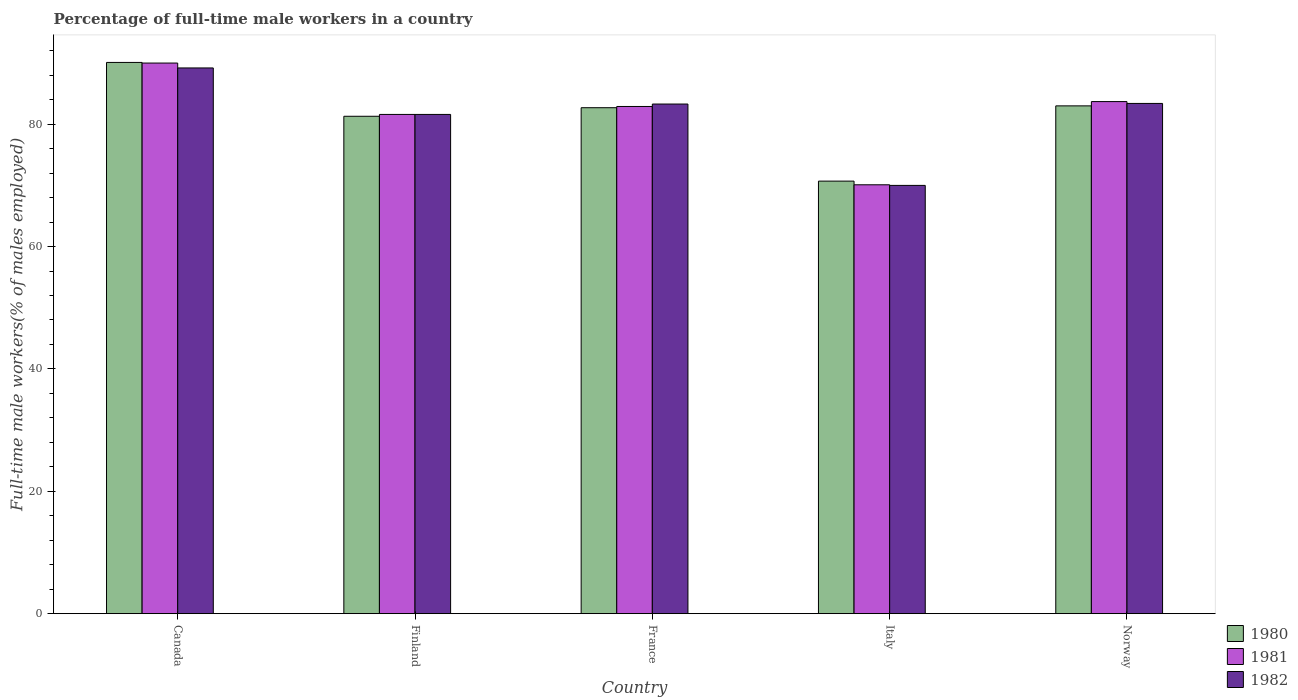How many different coloured bars are there?
Make the answer very short. 3. Are the number of bars per tick equal to the number of legend labels?
Make the answer very short. Yes. How many bars are there on the 1st tick from the left?
Provide a short and direct response. 3. What is the percentage of full-time male workers in 1980 in Canada?
Keep it short and to the point. 90.1. Across all countries, what is the maximum percentage of full-time male workers in 1981?
Give a very brief answer. 90. Across all countries, what is the minimum percentage of full-time male workers in 1982?
Give a very brief answer. 70. In which country was the percentage of full-time male workers in 1980 minimum?
Your answer should be compact. Italy. What is the total percentage of full-time male workers in 1980 in the graph?
Provide a succinct answer. 407.8. What is the difference between the percentage of full-time male workers in 1980 in Canada and that in Finland?
Provide a succinct answer. 8.8. What is the difference between the percentage of full-time male workers in 1981 in Italy and the percentage of full-time male workers in 1982 in Finland?
Your answer should be compact. -11.5. What is the average percentage of full-time male workers in 1980 per country?
Your answer should be compact. 81.56. What is the difference between the percentage of full-time male workers of/in 1980 and percentage of full-time male workers of/in 1981 in Canada?
Keep it short and to the point. 0.1. In how many countries, is the percentage of full-time male workers in 1982 greater than 4 %?
Your answer should be very brief. 5. What is the ratio of the percentage of full-time male workers in 1981 in France to that in Norway?
Offer a terse response. 0.99. Is the percentage of full-time male workers in 1982 in Canada less than that in France?
Make the answer very short. No. Is the difference between the percentage of full-time male workers in 1980 in Canada and Italy greater than the difference between the percentage of full-time male workers in 1981 in Canada and Italy?
Provide a succinct answer. No. What is the difference between the highest and the second highest percentage of full-time male workers in 1982?
Provide a short and direct response. 5.9. What is the difference between the highest and the lowest percentage of full-time male workers in 1980?
Your response must be concise. 19.4. What does the 1st bar from the right in Norway represents?
Give a very brief answer. 1982. Is it the case that in every country, the sum of the percentage of full-time male workers in 1981 and percentage of full-time male workers in 1982 is greater than the percentage of full-time male workers in 1980?
Give a very brief answer. Yes. How many bars are there?
Offer a very short reply. 15. Are all the bars in the graph horizontal?
Provide a short and direct response. No. What is the difference between two consecutive major ticks on the Y-axis?
Make the answer very short. 20. Are the values on the major ticks of Y-axis written in scientific E-notation?
Provide a short and direct response. No. Does the graph contain any zero values?
Make the answer very short. No. Does the graph contain grids?
Keep it short and to the point. No. Where does the legend appear in the graph?
Your answer should be compact. Bottom right. What is the title of the graph?
Keep it short and to the point. Percentage of full-time male workers in a country. What is the label or title of the X-axis?
Keep it short and to the point. Country. What is the label or title of the Y-axis?
Make the answer very short. Full-time male workers(% of males employed). What is the Full-time male workers(% of males employed) in 1980 in Canada?
Ensure brevity in your answer.  90.1. What is the Full-time male workers(% of males employed) in 1981 in Canada?
Your answer should be compact. 90. What is the Full-time male workers(% of males employed) of 1982 in Canada?
Your answer should be very brief. 89.2. What is the Full-time male workers(% of males employed) of 1980 in Finland?
Offer a very short reply. 81.3. What is the Full-time male workers(% of males employed) in 1981 in Finland?
Make the answer very short. 81.6. What is the Full-time male workers(% of males employed) in 1982 in Finland?
Provide a succinct answer. 81.6. What is the Full-time male workers(% of males employed) in 1980 in France?
Offer a very short reply. 82.7. What is the Full-time male workers(% of males employed) in 1981 in France?
Your response must be concise. 82.9. What is the Full-time male workers(% of males employed) in 1982 in France?
Offer a very short reply. 83.3. What is the Full-time male workers(% of males employed) in 1980 in Italy?
Make the answer very short. 70.7. What is the Full-time male workers(% of males employed) in 1981 in Italy?
Keep it short and to the point. 70.1. What is the Full-time male workers(% of males employed) of 1982 in Italy?
Give a very brief answer. 70. What is the Full-time male workers(% of males employed) in 1980 in Norway?
Ensure brevity in your answer.  83. What is the Full-time male workers(% of males employed) of 1981 in Norway?
Your response must be concise. 83.7. What is the Full-time male workers(% of males employed) of 1982 in Norway?
Ensure brevity in your answer.  83.4. Across all countries, what is the maximum Full-time male workers(% of males employed) of 1980?
Give a very brief answer. 90.1. Across all countries, what is the maximum Full-time male workers(% of males employed) of 1981?
Make the answer very short. 90. Across all countries, what is the maximum Full-time male workers(% of males employed) in 1982?
Your answer should be very brief. 89.2. Across all countries, what is the minimum Full-time male workers(% of males employed) of 1980?
Offer a very short reply. 70.7. Across all countries, what is the minimum Full-time male workers(% of males employed) of 1981?
Give a very brief answer. 70.1. Across all countries, what is the minimum Full-time male workers(% of males employed) in 1982?
Your response must be concise. 70. What is the total Full-time male workers(% of males employed) in 1980 in the graph?
Your answer should be compact. 407.8. What is the total Full-time male workers(% of males employed) in 1981 in the graph?
Provide a succinct answer. 408.3. What is the total Full-time male workers(% of males employed) in 1982 in the graph?
Offer a very short reply. 407.5. What is the difference between the Full-time male workers(% of males employed) of 1982 in Canada and that in Finland?
Offer a very short reply. 7.6. What is the difference between the Full-time male workers(% of males employed) in 1980 in Canada and that in France?
Your response must be concise. 7.4. What is the difference between the Full-time male workers(% of males employed) of 1982 in Canada and that in France?
Keep it short and to the point. 5.9. What is the difference between the Full-time male workers(% of males employed) of 1980 in Canada and that in Italy?
Keep it short and to the point. 19.4. What is the difference between the Full-time male workers(% of males employed) of 1980 in Canada and that in Norway?
Provide a succinct answer. 7.1. What is the difference between the Full-time male workers(% of males employed) in 1981 in Canada and that in Norway?
Ensure brevity in your answer.  6.3. What is the difference between the Full-time male workers(% of males employed) in 1981 in Finland and that in France?
Your response must be concise. -1.3. What is the difference between the Full-time male workers(% of males employed) of 1982 in Finland and that in France?
Make the answer very short. -1.7. What is the difference between the Full-time male workers(% of males employed) in 1980 in Finland and that in Italy?
Provide a succinct answer. 10.6. What is the difference between the Full-time male workers(% of males employed) in 1981 in Finland and that in Italy?
Make the answer very short. 11.5. What is the difference between the Full-time male workers(% of males employed) in 1982 in Finland and that in Italy?
Your response must be concise. 11.6. What is the difference between the Full-time male workers(% of males employed) in 1980 in Finland and that in Norway?
Make the answer very short. -1.7. What is the difference between the Full-time male workers(% of males employed) of 1982 in Finland and that in Norway?
Provide a succinct answer. -1.8. What is the difference between the Full-time male workers(% of males employed) in 1981 in France and that in Norway?
Your response must be concise. -0.8. What is the difference between the Full-time male workers(% of males employed) in 1980 in Italy and that in Norway?
Provide a succinct answer. -12.3. What is the difference between the Full-time male workers(% of males employed) in 1982 in Italy and that in Norway?
Provide a succinct answer. -13.4. What is the difference between the Full-time male workers(% of males employed) of 1981 in Canada and the Full-time male workers(% of males employed) of 1982 in Finland?
Provide a succinct answer. 8.4. What is the difference between the Full-time male workers(% of males employed) in 1980 in Canada and the Full-time male workers(% of males employed) in 1981 in France?
Keep it short and to the point. 7.2. What is the difference between the Full-time male workers(% of males employed) in 1980 in Canada and the Full-time male workers(% of males employed) in 1981 in Italy?
Your answer should be very brief. 20. What is the difference between the Full-time male workers(% of males employed) of 1980 in Canada and the Full-time male workers(% of males employed) of 1982 in Italy?
Offer a terse response. 20.1. What is the difference between the Full-time male workers(% of males employed) of 1981 in Canada and the Full-time male workers(% of males employed) of 1982 in Italy?
Make the answer very short. 20. What is the difference between the Full-time male workers(% of males employed) of 1980 in Canada and the Full-time male workers(% of males employed) of 1981 in Norway?
Your answer should be compact. 6.4. What is the difference between the Full-time male workers(% of males employed) in 1980 in Canada and the Full-time male workers(% of males employed) in 1982 in Norway?
Provide a succinct answer. 6.7. What is the difference between the Full-time male workers(% of males employed) in 1980 in Finland and the Full-time male workers(% of males employed) in 1981 in France?
Your answer should be very brief. -1.6. What is the difference between the Full-time male workers(% of males employed) of 1981 in Finland and the Full-time male workers(% of males employed) of 1982 in France?
Your answer should be very brief. -1.7. What is the difference between the Full-time male workers(% of males employed) of 1981 in Finland and the Full-time male workers(% of males employed) of 1982 in Italy?
Offer a terse response. 11.6. What is the difference between the Full-time male workers(% of males employed) of 1980 in Finland and the Full-time male workers(% of males employed) of 1982 in Norway?
Give a very brief answer. -2.1. What is the difference between the Full-time male workers(% of males employed) of 1980 in France and the Full-time male workers(% of males employed) of 1981 in Italy?
Provide a short and direct response. 12.6. What is the difference between the Full-time male workers(% of males employed) of 1980 in France and the Full-time male workers(% of males employed) of 1982 in Italy?
Provide a short and direct response. 12.7. What is the difference between the Full-time male workers(% of males employed) in 1981 in France and the Full-time male workers(% of males employed) in 1982 in Italy?
Ensure brevity in your answer.  12.9. What is the difference between the Full-time male workers(% of males employed) in 1980 in France and the Full-time male workers(% of males employed) in 1981 in Norway?
Offer a very short reply. -1. What is the difference between the Full-time male workers(% of males employed) of 1980 in Italy and the Full-time male workers(% of males employed) of 1982 in Norway?
Give a very brief answer. -12.7. What is the difference between the Full-time male workers(% of males employed) of 1981 in Italy and the Full-time male workers(% of males employed) of 1982 in Norway?
Offer a very short reply. -13.3. What is the average Full-time male workers(% of males employed) of 1980 per country?
Provide a succinct answer. 81.56. What is the average Full-time male workers(% of males employed) in 1981 per country?
Make the answer very short. 81.66. What is the average Full-time male workers(% of males employed) of 1982 per country?
Provide a succinct answer. 81.5. What is the difference between the Full-time male workers(% of males employed) in 1980 and Full-time male workers(% of males employed) in 1981 in Canada?
Offer a terse response. 0.1. What is the difference between the Full-time male workers(% of males employed) of 1980 and Full-time male workers(% of males employed) of 1982 in Canada?
Ensure brevity in your answer.  0.9. What is the difference between the Full-time male workers(% of males employed) in 1981 and Full-time male workers(% of males employed) in 1982 in Canada?
Give a very brief answer. 0.8. What is the difference between the Full-time male workers(% of males employed) of 1981 and Full-time male workers(% of males employed) of 1982 in Finland?
Your answer should be very brief. 0. What is the difference between the Full-time male workers(% of males employed) in 1980 and Full-time male workers(% of males employed) in 1981 in France?
Keep it short and to the point. -0.2. What is the difference between the Full-time male workers(% of males employed) in 1981 and Full-time male workers(% of males employed) in 1982 in France?
Give a very brief answer. -0.4. What is the difference between the Full-time male workers(% of males employed) in 1980 and Full-time male workers(% of males employed) in 1981 in Italy?
Offer a very short reply. 0.6. What is the difference between the Full-time male workers(% of males employed) of 1980 and Full-time male workers(% of males employed) of 1982 in Italy?
Give a very brief answer. 0.7. What is the difference between the Full-time male workers(% of males employed) of 1981 and Full-time male workers(% of males employed) of 1982 in Italy?
Provide a short and direct response. 0.1. What is the difference between the Full-time male workers(% of males employed) of 1981 and Full-time male workers(% of males employed) of 1982 in Norway?
Your answer should be compact. 0.3. What is the ratio of the Full-time male workers(% of males employed) of 1980 in Canada to that in Finland?
Ensure brevity in your answer.  1.11. What is the ratio of the Full-time male workers(% of males employed) of 1981 in Canada to that in Finland?
Offer a very short reply. 1.1. What is the ratio of the Full-time male workers(% of males employed) of 1982 in Canada to that in Finland?
Keep it short and to the point. 1.09. What is the ratio of the Full-time male workers(% of males employed) in 1980 in Canada to that in France?
Keep it short and to the point. 1.09. What is the ratio of the Full-time male workers(% of males employed) of 1981 in Canada to that in France?
Your response must be concise. 1.09. What is the ratio of the Full-time male workers(% of males employed) of 1982 in Canada to that in France?
Give a very brief answer. 1.07. What is the ratio of the Full-time male workers(% of males employed) in 1980 in Canada to that in Italy?
Offer a terse response. 1.27. What is the ratio of the Full-time male workers(% of males employed) of 1981 in Canada to that in Italy?
Your answer should be very brief. 1.28. What is the ratio of the Full-time male workers(% of males employed) in 1982 in Canada to that in Italy?
Provide a short and direct response. 1.27. What is the ratio of the Full-time male workers(% of males employed) in 1980 in Canada to that in Norway?
Offer a terse response. 1.09. What is the ratio of the Full-time male workers(% of males employed) in 1981 in Canada to that in Norway?
Ensure brevity in your answer.  1.08. What is the ratio of the Full-time male workers(% of males employed) of 1982 in Canada to that in Norway?
Provide a short and direct response. 1.07. What is the ratio of the Full-time male workers(% of males employed) of 1980 in Finland to that in France?
Your answer should be compact. 0.98. What is the ratio of the Full-time male workers(% of males employed) in 1981 in Finland to that in France?
Offer a terse response. 0.98. What is the ratio of the Full-time male workers(% of males employed) in 1982 in Finland to that in France?
Keep it short and to the point. 0.98. What is the ratio of the Full-time male workers(% of males employed) of 1980 in Finland to that in Italy?
Keep it short and to the point. 1.15. What is the ratio of the Full-time male workers(% of males employed) in 1981 in Finland to that in Italy?
Make the answer very short. 1.16. What is the ratio of the Full-time male workers(% of males employed) of 1982 in Finland to that in Italy?
Keep it short and to the point. 1.17. What is the ratio of the Full-time male workers(% of males employed) of 1980 in Finland to that in Norway?
Provide a succinct answer. 0.98. What is the ratio of the Full-time male workers(% of males employed) of 1981 in Finland to that in Norway?
Provide a short and direct response. 0.97. What is the ratio of the Full-time male workers(% of males employed) in 1982 in Finland to that in Norway?
Give a very brief answer. 0.98. What is the ratio of the Full-time male workers(% of males employed) in 1980 in France to that in Italy?
Keep it short and to the point. 1.17. What is the ratio of the Full-time male workers(% of males employed) of 1981 in France to that in Italy?
Your answer should be compact. 1.18. What is the ratio of the Full-time male workers(% of males employed) of 1982 in France to that in Italy?
Ensure brevity in your answer.  1.19. What is the ratio of the Full-time male workers(% of males employed) of 1980 in France to that in Norway?
Make the answer very short. 1. What is the ratio of the Full-time male workers(% of males employed) of 1981 in France to that in Norway?
Give a very brief answer. 0.99. What is the ratio of the Full-time male workers(% of males employed) in 1982 in France to that in Norway?
Provide a short and direct response. 1. What is the ratio of the Full-time male workers(% of males employed) of 1980 in Italy to that in Norway?
Make the answer very short. 0.85. What is the ratio of the Full-time male workers(% of males employed) of 1981 in Italy to that in Norway?
Your answer should be compact. 0.84. What is the ratio of the Full-time male workers(% of males employed) of 1982 in Italy to that in Norway?
Give a very brief answer. 0.84. What is the difference between the highest and the second highest Full-time male workers(% of males employed) of 1980?
Offer a very short reply. 7.1. What is the difference between the highest and the lowest Full-time male workers(% of males employed) of 1982?
Your answer should be very brief. 19.2. 